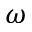<formula> <loc_0><loc_0><loc_500><loc_500>\omega</formula> 